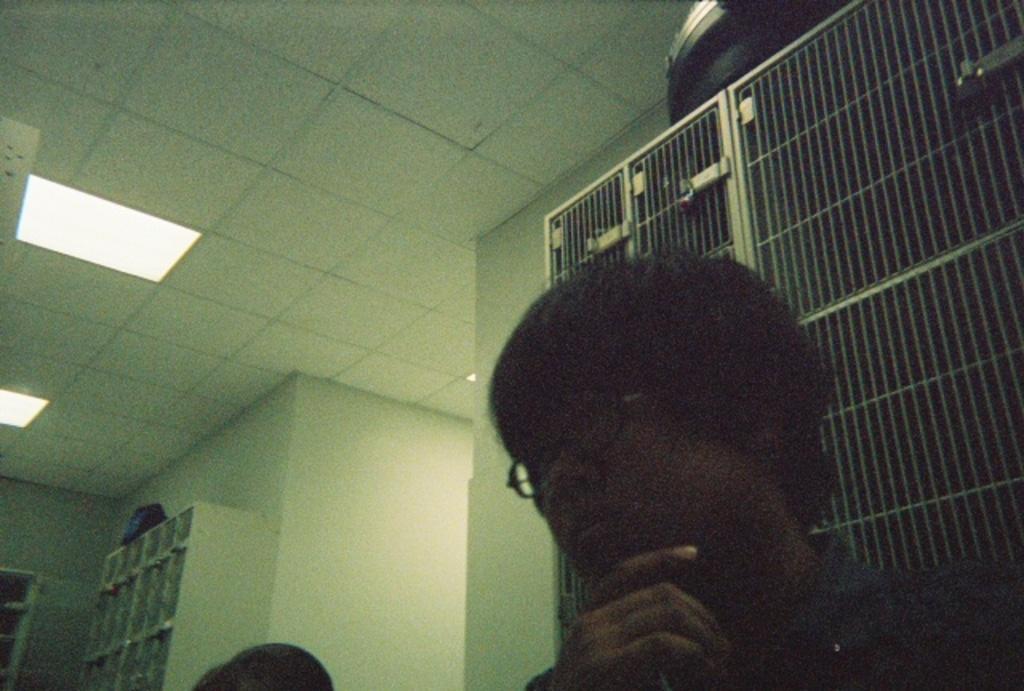Could you give a brief overview of what you see in this image? There are two persons at the bottom of this image, and there is a wall in the background. There are some lights attached to the roof. 